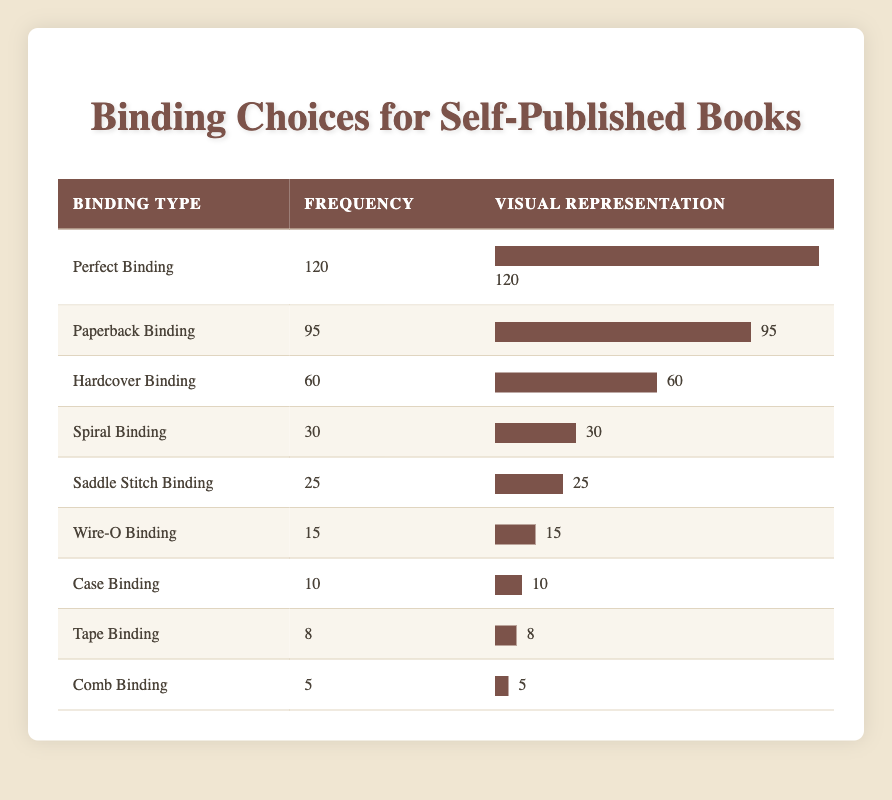What is the most popular binding choice for self-published books? By examining the frequency column in the table, we can see that "Perfect Binding" has the highest frequency value of 120, indicating it is the most popular choice.
Answer: Perfect Binding How many more copies are done in Perfect Binding compared to Saddle Stitch Binding? The frequency for Perfect Binding is 120 and for Saddle Stitch Binding is 25. To find the difference, we subtract 25 from 120, which equals 95.
Answer: 95 Is Hardcover Binding more frequently chosen than Wire-O Binding? The data shows that "Hardcover Binding" has a frequency of 60 while "Wire-O Binding" has a frequency of 15. Since 60 is greater than 15, the statement is true.
Answer: Yes What are the total frequencies of Spiral, Saddle Stitch, and Comb Binding combined? The frequencies are 30 for Spiral Binding, 25 for Saddle Stitch Binding, and 5 for Comb Binding. We add these values: 30 + 25 + 5 = 60.
Answer: 60 What is the average frequency of the binding choices listed in the table? To find the average, sum the frequencies of all binding choices: 120 + 95 + 60 + 30 + 25 + 15 + 10 + 8 + 5 = 368. There are 9 binding types, so the average is 368/9, which equals approximately 40.89.
Answer: 40.89 Has the frequency of Tape Binding exceeded that of Case Binding? Tape Binding has a frequency of 8 and Case Binding has a frequency of 10. Since 8 is not greater than 10, the statement is false.
Answer: No What is the proportion of Paperback Binding compared to the total frequency of all binding types? The frequency of Paperback Binding is 95, and the total frequency is 368. To find the proportion, we calculate 95/368, which is approximately 0.257, or 25.7%.
Answer: 25.7% Which binding type has the least frequency? Looking at the frequencies, "Comb Binding" has the lowest frequency at 5, making it the least chosen binding type.
Answer: Comb Binding 